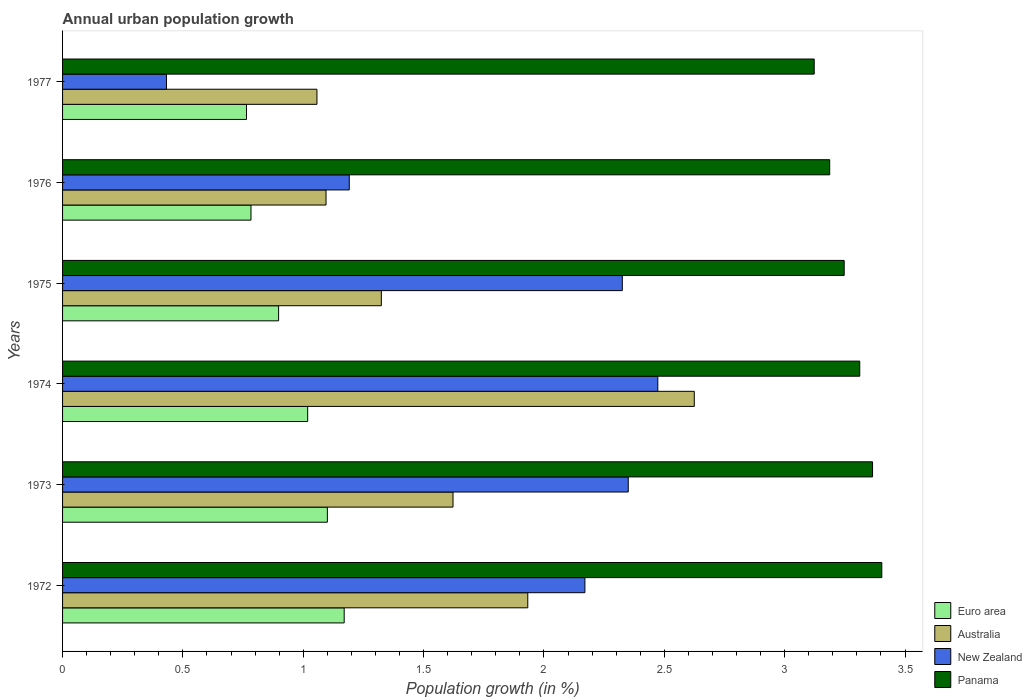How many groups of bars are there?
Offer a terse response. 6. Are the number of bars on each tick of the Y-axis equal?
Offer a terse response. Yes. How many bars are there on the 1st tick from the top?
Give a very brief answer. 4. How many bars are there on the 5th tick from the bottom?
Offer a very short reply. 4. What is the label of the 3rd group of bars from the top?
Keep it short and to the point. 1975. What is the percentage of urban population growth in Australia in 1975?
Make the answer very short. 1.32. Across all years, what is the maximum percentage of urban population growth in Australia?
Provide a succinct answer. 2.62. Across all years, what is the minimum percentage of urban population growth in Australia?
Keep it short and to the point. 1.06. In which year was the percentage of urban population growth in Euro area maximum?
Give a very brief answer. 1972. In which year was the percentage of urban population growth in Australia minimum?
Keep it short and to the point. 1977. What is the total percentage of urban population growth in New Zealand in the graph?
Offer a terse response. 10.94. What is the difference between the percentage of urban population growth in Panama in 1973 and that in 1974?
Your answer should be compact. 0.05. What is the difference between the percentage of urban population growth in Euro area in 1976 and the percentage of urban population growth in Australia in 1974?
Give a very brief answer. -1.84. What is the average percentage of urban population growth in Australia per year?
Your answer should be very brief. 1.61. In the year 1975, what is the difference between the percentage of urban population growth in Euro area and percentage of urban population growth in Australia?
Provide a succinct answer. -0.43. In how many years, is the percentage of urban population growth in New Zealand greater than 0.5 %?
Offer a terse response. 5. What is the ratio of the percentage of urban population growth in Australia in 1973 to that in 1976?
Provide a succinct answer. 1.48. What is the difference between the highest and the second highest percentage of urban population growth in Euro area?
Make the answer very short. 0.07. What is the difference between the highest and the lowest percentage of urban population growth in Panama?
Make the answer very short. 0.28. In how many years, is the percentage of urban population growth in Panama greater than the average percentage of urban population growth in Panama taken over all years?
Give a very brief answer. 3. Is it the case that in every year, the sum of the percentage of urban population growth in Panama and percentage of urban population growth in New Zealand is greater than the sum of percentage of urban population growth in Australia and percentage of urban population growth in Euro area?
Your answer should be compact. Yes. What does the 2nd bar from the top in 1976 represents?
Give a very brief answer. New Zealand. Is it the case that in every year, the sum of the percentage of urban population growth in Euro area and percentage of urban population growth in Panama is greater than the percentage of urban population growth in Australia?
Give a very brief answer. Yes. How many bars are there?
Your answer should be very brief. 24. Are all the bars in the graph horizontal?
Ensure brevity in your answer.  Yes. How many years are there in the graph?
Ensure brevity in your answer.  6. Are the values on the major ticks of X-axis written in scientific E-notation?
Your answer should be compact. No. Does the graph contain any zero values?
Your answer should be compact. No. Does the graph contain grids?
Give a very brief answer. No. How are the legend labels stacked?
Give a very brief answer. Vertical. What is the title of the graph?
Your answer should be compact. Annual urban population growth. Does "Cote d'Ivoire" appear as one of the legend labels in the graph?
Give a very brief answer. No. What is the label or title of the X-axis?
Keep it short and to the point. Population growth (in %). What is the label or title of the Y-axis?
Your response must be concise. Years. What is the Population growth (in %) in Euro area in 1972?
Provide a short and direct response. 1.17. What is the Population growth (in %) of Australia in 1972?
Offer a terse response. 1.93. What is the Population growth (in %) of New Zealand in 1972?
Provide a succinct answer. 2.17. What is the Population growth (in %) of Panama in 1972?
Offer a terse response. 3.4. What is the Population growth (in %) of Euro area in 1973?
Your response must be concise. 1.1. What is the Population growth (in %) of Australia in 1973?
Make the answer very short. 1.62. What is the Population growth (in %) of New Zealand in 1973?
Keep it short and to the point. 2.35. What is the Population growth (in %) in Panama in 1973?
Give a very brief answer. 3.37. What is the Population growth (in %) in Euro area in 1974?
Provide a short and direct response. 1.02. What is the Population growth (in %) of Australia in 1974?
Offer a very short reply. 2.62. What is the Population growth (in %) in New Zealand in 1974?
Keep it short and to the point. 2.47. What is the Population growth (in %) in Panama in 1974?
Provide a succinct answer. 3.31. What is the Population growth (in %) of Euro area in 1975?
Make the answer very short. 0.9. What is the Population growth (in %) in Australia in 1975?
Your answer should be very brief. 1.32. What is the Population growth (in %) of New Zealand in 1975?
Make the answer very short. 2.33. What is the Population growth (in %) in Panama in 1975?
Give a very brief answer. 3.25. What is the Population growth (in %) in Euro area in 1976?
Give a very brief answer. 0.78. What is the Population growth (in %) of Australia in 1976?
Give a very brief answer. 1.09. What is the Population growth (in %) of New Zealand in 1976?
Make the answer very short. 1.19. What is the Population growth (in %) in Panama in 1976?
Offer a terse response. 3.19. What is the Population growth (in %) of Euro area in 1977?
Your answer should be very brief. 0.76. What is the Population growth (in %) in Australia in 1977?
Your answer should be compact. 1.06. What is the Population growth (in %) in New Zealand in 1977?
Make the answer very short. 0.43. What is the Population growth (in %) of Panama in 1977?
Your answer should be very brief. 3.12. Across all years, what is the maximum Population growth (in %) of Euro area?
Your answer should be compact. 1.17. Across all years, what is the maximum Population growth (in %) of Australia?
Give a very brief answer. 2.62. Across all years, what is the maximum Population growth (in %) of New Zealand?
Keep it short and to the point. 2.47. Across all years, what is the maximum Population growth (in %) of Panama?
Ensure brevity in your answer.  3.4. Across all years, what is the minimum Population growth (in %) in Euro area?
Make the answer very short. 0.76. Across all years, what is the minimum Population growth (in %) of Australia?
Offer a terse response. 1.06. Across all years, what is the minimum Population growth (in %) in New Zealand?
Your answer should be compact. 0.43. Across all years, what is the minimum Population growth (in %) of Panama?
Your answer should be very brief. 3.12. What is the total Population growth (in %) in Euro area in the graph?
Your answer should be very brief. 5.73. What is the total Population growth (in %) of Australia in the graph?
Make the answer very short. 9.66. What is the total Population growth (in %) in New Zealand in the graph?
Ensure brevity in your answer.  10.94. What is the total Population growth (in %) in Panama in the graph?
Your answer should be compact. 19.64. What is the difference between the Population growth (in %) of Euro area in 1972 and that in 1973?
Give a very brief answer. 0.07. What is the difference between the Population growth (in %) in Australia in 1972 and that in 1973?
Your answer should be compact. 0.31. What is the difference between the Population growth (in %) in New Zealand in 1972 and that in 1973?
Your answer should be very brief. -0.18. What is the difference between the Population growth (in %) of Panama in 1972 and that in 1973?
Your response must be concise. 0.04. What is the difference between the Population growth (in %) of Euro area in 1972 and that in 1974?
Make the answer very short. 0.15. What is the difference between the Population growth (in %) of Australia in 1972 and that in 1974?
Your answer should be compact. -0.69. What is the difference between the Population growth (in %) in New Zealand in 1972 and that in 1974?
Offer a terse response. -0.3. What is the difference between the Population growth (in %) of Panama in 1972 and that in 1974?
Keep it short and to the point. 0.09. What is the difference between the Population growth (in %) of Euro area in 1972 and that in 1975?
Offer a terse response. 0.27. What is the difference between the Population growth (in %) in Australia in 1972 and that in 1975?
Offer a terse response. 0.61. What is the difference between the Population growth (in %) of New Zealand in 1972 and that in 1975?
Keep it short and to the point. -0.16. What is the difference between the Population growth (in %) of Panama in 1972 and that in 1975?
Give a very brief answer. 0.16. What is the difference between the Population growth (in %) of Euro area in 1972 and that in 1976?
Ensure brevity in your answer.  0.39. What is the difference between the Population growth (in %) of Australia in 1972 and that in 1976?
Provide a short and direct response. 0.84. What is the difference between the Population growth (in %) of New Zealand in 1972 and that in 1976?
Your answer should be compact. 0.98. What is the difference between the Population growth (in %) of Panama in 1972 and that in 1976?
Ensure brevity in your answer.  0.22. What is the difference between the Population growth (in %) in Euro area in 1972 and that in 1977?
Give a very brief answer. 0.41. What is the difference between the Population growth (in %) of Australia in 1972 and that in 1977?
Your response must be concise. 0.88. What is the difference between the Population growth (in %) of New Zealand in 1972 and that in 1977?
Your answer should be compact. 1.74. What is the difference between the Population growth (in %) in Panama in 1972 and that in 1977?
Offer a terse response. 0.28. What is the difference between the Population growth (in %) in Euro area in 1973 and that in 1974?
Offer a terse response. 0.08. What is the difference between the Population growth (in %) in Australia in 1973 and that in 1974?
Provide a succinct answer. -1. What is the difference between the Population growth (in %) of New Zealand in 1973 and that in 1974?
Your answer should be very brief. -0.12. What is the difference between the Population growth (in %) of Panama in 1973 and that in 1974?
Make the answer very short. 0.05. What is the difference between the Population growth (in %) in Euro area in 1973 and that in 1975?
Keep it short and to the point. 0.2. What is the difference between the Population growth (in %) in Australia in 1973 and that in 1975?
Provide a succinct answer. 0.3. What is the difference between the Population growth (in %) in New Zealand in 1973 and that in 1975?
Offer a very short reply. 0.02. What is the difference between the Population growth (in %) of Panama in 1973 and that in 1975?
Your response must be concise. 0.12. What is the difference between the Population growth (in %) of Euro area in 1973 and that in 1976?
Offer a terse response. 0.32. What is the difference between the Population growth (in %) of Australia in 1973 and that in 1976?
Provide a succinct answer. 0.53. What is the difference between the Population growth (in %) of New Zealand in 1973 and that in 1976?
Provide a short and direct response. 1.16. What is the difference between the Population growth (in %) of Panama in 1973 and that in 1976?
Offer a terse response. 0.18. What is the difference between the Population growth (in %) in Euro area in 1973 and that in 1977?
Ensure brevity in your answer.  0.34. What is the difference between the Population growth (in %) of Australia in 1973 and that in 1977?
Your response must be concise. 0.57. What is the difference between the Population growth (in %) in New Zealand in 1973 and that in 1977?
Your answer should be very brief. 1.92. What is the difference between the Population growth (in %) in Panama in 1973 and that in 1977?
Give a very brief answer. 0.24. What is the difference between the Population growth (in %) of Euro area in 1974 and that in 1975?
Provide a succinct answer. 0.12. What is the difference between the Population growth (in %) in Australia in 1974 and that in 1975?
Your answer should be very brief. 1.3. What is the difference between the Population growth (in %) of New Zealand in 1974 and that in 1975?
Make the answer very short. 0.15. What is the difference between the Population growth (in %) in Panama in 1974 and that in 1975?
Make the answer very short. 0.06. What is the difference between the Population growth (in %) of Euro area in 1974 and that in 1976?
Your answer should be very brief. 0.24. What is the difference between the Population growth (in %) of Australia in 1974 and that in 1976?
Your answer should be compact. 1.53. What is the difference between the Population growth (in %) of New Zealand in 1974 and that in 1976?
Give a very brief answer. 1.28. What is the difference between the Population growth (in %) in Panama in 1974 and that in 1976?
Provide a short and direct response. 0.12. What is the difference between the Population growth (in %) of Euro area in 1974 and that in 1977?
Give a very brief answer. 0.25. What is the difference between the Population growth (in %) of Australia in 1974 and that in 1977?
Your answer should be very brief. 1.57. What is the difference between the Population growth (in %) in New Zealand in 1974 and that in 1977?
Offer a very short reply. 2.04. What is the difference between the Population growth (in %) of Panama in 1974 and that in 1977?
Offer a very short reply. 0.19. What is the difference between the Population growth (in %) of Euro area in 1975 and that in 1976?
Make the answer very short. 0.11. What is the difference between the Population growth (in %) of Australia in 1975 and that in 1976?
Provide a short and direct response. 0.23. What is the difference between the Population growth (in %) of New Zealand in 1975 and that in 1976?
Provide a succinct answer. 1.13. What is the difference between the Population growth (in %) in Panama in 1975 and that in 1976?
Keep it short and to the point. 0.06. What is the difference between the Population growth (in %) in Euro area in 1975 and that in 1977?
Your response must be concise. 0.13. What is the difference between the Population growth (in %) in Australia in 1975 and that in 1977?
Provide a succinct answer. 0.27. What is the difference between the Population growth (in %) of New Zealand in 1975 and that in 1977?
Make the answer very short. 1.89. What is the difference between the Population growth (in %) of Panama in 1975 and that in 1977?
Offer a very short reply. 0.12. What is the difference between the Population growth (in %) in Euro area in 1976 and that in 1977?
Your answer should be very brief. 0.02. What is the difference between the Population growth (in %) of Australia in 1976 and that in 1977?
Your response must be concise. 0.04. What is the difference between the Population growth (in %) in New Zealand in 1976 and that in 1977?
Provide a succinct answer. 0.76. What is the difference between the Population growth (in %) of Panama in 1976 and that in 1977?
Give a very brief answer. 0.06. What is the difference between the Population growth (in %) of Euro area in 1972 and the Population growth (in %) of Australia in 1973?
Your answer should be compact. -0.45. What is the difference between the Population growth (in %) of Euro area in 1972 and the Population growth (in %) of New Zealand in 1973?
Give a very brief answer. -1.18. What is the difference between the Population growth (in %) in Euro area in 1972 and the Population growth (in %) in Panama in 1973?
Your answer should be compact. -2.2. What is the difference between the Population growth (in %) in Australia in 1972 and the Population growth (in %) in New Zealand in 1973?
Your response must be concise. -0.42. What is the difference between the Population growth (in %) in Australia in 1972 and the Population growth (in %) in Panama in 1973?
Your answer should be compact. -1.43. What is the difference between the Population growth (in %) of New Zealand in 1972 and the Population growth (in %) of Panama in 1973?
Make the answer very short. -1.2. What is the difference between the Population growth (in %) in Euro area in 1972 and the Population growth (in %) in Australia in 1974?
Provide a succinct answer. -1.45. What is the difference between the Population growth (in %) in Euro area in 1972 and the Population growth (in %) in New Zealand in 1974?
Keep it short and to the point. -1.3. What is the difference between the Population growth (in %) of Euro area in 1972 and the Population growth (in %) of Panama in 1974?
Offer a terse response. -2.14. What is the difference between the Population growth (in %) in Australia in 1972 and the Population growth (in %) in New Zealand in 1974?
Ensure brevity in your answer.  -0.54. What is the difference between the Population growth (in %) in Australia in 1972 and the Population growth (in %) in Panama in 1974?
Provide a succinct answer. -1.38. What is the difference between the Population growth (in %) of New Zealand in 1972 and the Population growth (in %) of Panama in 1974?
Your response must be concise. -1.14. What is the difference between the Population growth (in %) in Euro area in 1972 and the Population growth (in %) in Australia in 1975?
Provide a short and direct response. -0.15. What is the difference between the Population growth (in %) in Euro area in 1972 and the Population growth (in %) in New Zealand in 1975?
Provide a succinct answer. -1.16. What is the difference between the Population growth (in %) in Euro area in 1972 and the Population growth (in %) in Panama in 1975?
Provide a short and direct response. -2.08. What is the difference between the Population growth (in %) in Australia in 1972 and the Population growth (in %) in New Zealand in 1975?
Make the answer very short. -0.39. What is the difference between the Population growth (in %) of Australia in 1972 and the Population growth (in %) of Panama in 1975?
Your answer should be compact. -1.31. What is the difference between the Population growth (in %) in New Zealand in 1972 and the Population growth (in %) in Panama in 1975?
Provide a short and direct response. -1.08. What is the difference between the Population growth (in %) of Euro area in 1972 and the Population growth (in %) of Australia in 1976?
Ensure brevity in your answer.  0.08. What is the difference between the Population growth (in %) in Euro area in 1972 and the Population growth (in %) in New Zealand in 1976?
Offer a terse response. -0.02. What is the difference between the Population growth (in %) in Euro area in 1972 and the Population growth (in %) in Panama in 1976?
Ensure brevity in your answer.  -2.02. What is the difference between the Population growth (in %) in Australia in 1972 and the Population growth (in %) in New Zealand in 1976?
Make the answer very short. 0.74. What is the difference between the Population growth (in %) in Australia in 1972 and the Population growth (in %) in Panama in 1976?
Offer a very short reply. -1.25. What is the difference between the Population growth (in %) of New Zealand in 1972 and the Population growth (in %) of Panama in 1976?
Make the answer very short. -1.02. What is the difference between the Population growth (in %) in Euro area in 1972 and the Population growth (in %) in Australia in 1977?
Your answer should be very brief. 0.11. What is the difference between the Population growth (in %) in Euro area in 1972 and the Population growth (in %) in New Zealand in 1977?
Provide a short and direct response. 0.74. What is the difference between the Population growth (in %) of Euro area in 1972 and the Population growth (in %) of Panama in 1977?
Give a very brief answer. -1.95. What is the difference between the Population growth (in %) of Australia in 1972 and the Population growth (in %) of New Zealand in 1977?
Your answer should be very brief. 1.5. What is the difference between the Population growth (in %) of Australia in 1972 and the Population growth (in %) of Panama in 1977?
Provide a short and direct response. -1.19. What is the difference between the Population growth (in %) in New Zealand in 1972 and the Population growth (in %) in Panama in 1977?
Your response must be concise. -0.95. What is the difference between the Population growth (in %) in Euro area in 1973 and the Population growth (in %) in Australia in 1974?
Ensure brevity in your answer.  -1.52. What is the difference between the Population growth (in %) of Euro area in 1973 and the Population growth (in %) of New Zealand in 1974?
Give a very brief answer. -1.37. What is the difference between the Population growth (in %) of Euro area in 1973 and the Population growth (in %) of Panama in 1974?
Your answer should be compact. -2.21. What is the difference between the Population growth (in %) in Australia in 1973 and the Population growth (in %) in New Zealand in 1974?
Offer a terse response. -0.85. What is the difference between the Population growth (in %) in Australia in 1973 and the Population growth (in %) in Panama in 1974?
Your answer should be compact. -1.69. What is the difference between the Population growth (in %) of New Zealand in 1973 and the Population growth (in %) of Panama in 1974?
Offer a terse response. -0.96. What is the difference between the Population growth (in %) of Euro area in 1973 and the Population growth (in %) of Australia in 1975?
Your answer should be compact. -0.22. What is the difference between the Population growth (in %) of Euro area in 1973 and the Population growth (in %) of New Zealand in 1975?
Offer a very short reply. -1.23. What is the difference between the Population growth (in %) in Euro area in 1973 and the Population growth (in %) in Panama in 1975?
Provide a short and direct response. -2.15. What is the difference between the Population growth (in %) in Australia in 1973 and the Population growth (in %) in New Zealand in 1975?
Your answer should be compact. -0.7. What is the difference between the Population growth (in %) of Australia in 1973 and the Population growth (in %) of Panama in 1975?
Your answer should be compact. -1.63. What is the difference between the Population growth (in %) in New Zealand in 1973 and the Population growth (in %) in Panama in 1975?
Keep it short and to the point. -0.9. What is the difference between the Population growth (in %) in Euro area in 1973 and the Population growth (in %) in Australia in 1976?
Make the answer very short. 0.01. What is the difference between the Population growth (in %) in Euro area in 1973 and the Population growth (in %) in New Zealand in 1976?
Make the answer very short. -0.09. What is the difference between the Population growth (in %) in Euro area in 1973 and the Population growth (in %) in Panama in 1976?
Offer a very short reply. -2.09. What is the difference between the Population growth (in %) of Australia in 1973 and the Population growth (in %) of New Zealand in 1976?
Ensure brevity in your answer.  0.43. What is the difference between the Population growth (in %) in Australia in 1973 and the Population growth (in %) in Panama in 1976?
Your response must be concise. -1.56. What is the difference between the Population growth (in %) of New Zealand in 1973 and the Population growth (in %) of Panama in 1976?
Ensure brevity in your answer.  -0.84. What is the difference between the Population growth (in %) of Euro area in 1973 and the Population growth (in %) of Australia in 1977?
Ensure brevity in your answer.  0.04. What is the difference between the Population growth (in %) of Euro area in 1973 and the Population growth (in %) of New Zealand in 1977?
Offer a very short reply. 0.67. What is the difference between the Population growth (in %) in Euro area in 1973 and the Population growth (in %) in Panama in 1977?
Ensure brevity in your answer.  -2.02. What is the difference between the Population growth (in %) in Australia in 1973 and the Population growth (in %) in New Zealand in 1977?
Your answer should be compact. 1.19. What is the difference between the Population growth (in %) of Australia in 1973 and the Population growth (in %) of Panama in 1977?
Offer a terse response. -1.5. What is the difference between the Population growth (in %) in New Zealand in 1973 and the Population growth (in %) in Panama in 1977?
Give a very brief answer. -0.77. What is the difference between the Population growth (in %) of Euro area in 1974 and the Population growth (in %) of Australia in 1975?
Your answer should be compact. -0.31. What is the difference between the Population growth (in %) in Euro area in 1974 and the Population growth (in %) in New Zealand in 1975?
Keep it short and to the point. -1.31. What is the difference between the Population growth (in %) in Euro area in 1974 and the Population growth (in %) in Panama in 1975?
Provide a short and direct response. -2.23. What is the difference between the Population growth (in %) of Australia in 1974 and the Population growth (in %) of New Zealand in 1975?
Keep it short and to the point. 0.3. What is the difference between the Population growth (in %) in Australia in 1974 and the Population growth (in %) in Panama in 1975?
Offer a very short reply. -0.62. What is the difference between the Population growth (in %) of New Zealand in 1974 and the Population growth (in %) of Panama in 1975?
Your response must be concise. -0.77. What is the difference between the Population growth (in %) of Euro area in 1974 and the Population growth (in %) of Australia in 1976?
Ensure brevity in your answer.  -0.08. What is the difference between the Population growth (in %) of Euro area in 1974 and the Population growth (in %) of New Zealand in 1976?
Your response must be concise. -0.17. What is the difference between the Population growth (in %) in Euro area in 1974 and the Population growth (in %) in Panama in 1976?
Keep it short and to the point. -2.17. What is the difference between the Population growth (in %) in Australia in 1974 and the Population growth (in %) in New Zealand in 1976?
Your response must be concise. 1.43. What is the difference between the Population growth (in %) of Australia in 1974 and the Population growth (in %) of Panama in 1976?
Provide a short and direct response. -0.56. What is the difference between the Population growth (in %) of New Zealand in 1974 and the Population growth (in %) of Panama in 1976?
Give a very brief answer. -0.71. What is the difference between the Population growth (in %) of Euro area in 1974 and the Population growth (in %) of Australia in 1977?
Your answer should be compact. -0.04. What is the difference between the Population growth (in %) in Euro area in 1974 and the Population growth (in %) in New Zealand in 1977?
Provide a succinct answer. 0.59. What is the difference between the Population growth (in %) of Euro area in 1974 and the Population growth (in %) of Panama in 1977?
Provide a short and direct response. -2.1. What is the difference between the Population growth (in %) of Australia in 1974 and the Population growth (in %) of New Zealand in 1977?
Your response must be concise. 2.19. What is the difference between the Population growth (in %) in Australia in 1974 and the Population growth (in %) in Panama in 1977?
Your answer should be very brief. -0.5. What is the difference between the Population growth (in %) of New Zealand in 1974 and the Population growth (in %) of Panama in 1977?
Provide a short and direct response. -0.65. What is the difference between the Population growth (in %) in Euro area in 1975 and the Population growth (in %) in Australia in 1976?
Provide a short and direct response. -0.2. What is the difference between the Population growth (in %) in Euro area in 1975 and the Population growth (in %) in New Zealand in 1976?
Give a very brief answer. -0.29. What is the difference between the Population growth (in %) in Euro area in 1975 and the Population growth (in %) in Panama in 1976?
Give a very brief answer. -2.29. What is the difference between the Population growth (in %) in Australia in 1975 and the Population growth (in %) in New Zealand in 1976?
Provide a succinct answer. 0.13. What is the difference between the Population growth (in %) of Australia in 1975 and the Population growth (in %) of Panama in 1976?
Ensure brevity in your answer.  -1.86. What is the difference between the Population growth (in %) of New Zealand in 1975 and the Population growth (in %) of Panama in 1976?
Give a very brief answer. -0.86. What is the difference between the Population growth (in %) of Euro area in 1975 and the Population growth (in %) of Australia in 1977?
Keep it short and to the point. -0.16. What is the difference between the Population growth (in %) in Euro area in 1975 and the Population growth (in %) in New Zealand in 1977?
Offer a very short reply. 0.47. What is the difference between the Population growth (in %) of Euro area in 1975 and the Population growth (in %) of Panama in 1977?
Provide a succinct answer. -2.23. What is the difference between the Population growth (in %) of Australia in 1975 and the Population growth (in %) of New Zealand in 1977?
Ensure brevity in your answer.  0.89. What is the difference between the Population growth (in %) of Australia in 1975 and the Population growth (in %) of Panama in 1977?
Your response must be concise. -1.8. What is the difference between the Population growth (in %) in New Zealand in 1975 and the Population growth (in %) in Panama in 1977?
Offer a very short reply. -0.8. What is the difference between the Population growth (in %) in Euro area in 1976 and the Population growth (in %) in Australia in 1977?
Your answer should be very brief. -0.27. What is the difference between the Population growth (in %) in Euro area in 1976 and the Population growth (in %) in New Zealand in 1977?
Your response must be concise. 0.35. What is the difference between the Population growth (in %) in Euro area in 1976 and the Population growth (in %) in Panama in 1977?
Offer a very short reply. -2.34. What is the difference between the Population growth (in %) of Australia in 1976 and the Population growth (in %) of New Zealand in 1977?
Your answer should be very brief. 0.66. What is the difference between the Population growth (in %) in Australia in 1976 and the Population growth (in %) in Panama in 1977?
Your answer should be compact. -2.03. What is the difference between the Population growth (in %) of New Zealand in 1976 and the Population growth (in %) of Panama in 1977?
Your answer should be very brief. -1.93. What is the average Population growth (in %) in Euro area per year?
Make the answer very short. 0.96. What is the average Population growth (in %) in Australia per year?
Make the answer very short. 1.61. What is the average Population growth (in %) in New Zealand per year?
Offer a very short reply. 1.82. What is the average Population growth (in %) in Panama per year?
Provide a short and direct response. 3.27. In the year 1972, what is the difference between the Population growth (in %) in Euro area and Population growth (in %) in Australia?
Offer a very short reply. -0.76. In the year 1972, what is the difference between the Population growth (in %) of Euro area and Population growth (in %) of New Zealand?
Give a very brief answer. -1. In the year 1972, what is the difference between the Population growth (in %) of Euro area and Population growth (in %) of Panama?
Provide a short and direct response. -2.23. In the year 1972, what is the difference between the Population growth (in %) of Australia and Population growth (in %) of New Zealand?
Your answer should be compact. -0.24. In the year 1972, what is the difference between the Population growth (in %) in Australia and Population growth (in %) in Panama?
Your response must be concise. -1.47. In the year 1972, what is the difference between the Population growth (in %) of New Zealand and Population growth (in %) of Panama?
Your answer should be compact. -1.23. In the year 1973, what is the difference between the Population growth (in %) in Euro area and Population growth (in %) in Australia?
Give a very brief answer. -0.52. In the year 1973, what is the difference between the Population growth (in %) of Euro area and Population growth (in %) of New Zealand?
Your answer should be compact. -1.25. In the year 1973, what is the difference between the Population growth (in %) of Euro area and Population growth (in %) of Panama?
Ensure brevity in your answer.  -2.26. In the year 1973, what is the difference between the Population growth (in %) of Australia and Population growth (in %) of New Zealand?
Offer a terse response. -0.73. In the year 1973, what is the difference between the Population growth (in %) of Australia and Population growth (in %) of Panama?
Provide a succinct answer. -1.74. In the year 1973, what is the difference between the Population growth (in %) of New Zealand and Population growth (in %) of Panama?
Provide a succinct answer. -1.01. In the year 1974, what is the difference between the Population growth (in %) of Euro area and Population growth (in %) of Australia?
Your answer should be compact. -1.61. In the year 1974, what is the difference between the Population growth (in %) in Euro area and Population growth (in %) in New Zealand?
Offer a very short reply. -1.45. In the year 1974, what is the difference between the Population growth (in %) in Euro area and Population growth (in %) in Panama?
Give a very brief answer. -2.29. In the year 1974, what is the difference between the Population growth (in %) of Australia and Population growth (in %) of New Zealand?
Keep it short and to the point. 0.15. In the year 1974, what is the difference between the Population growth (in %) of Australia and Population growth (in %) of Panama?
Your response must be concise. -0.69. In the year 1974, what is the difference between the Population growth (in %) of New Zealand and Population growth (in %) of Panama?
Provide a succinct answer. -0.84. In the year 1975, what is the difference between the Population growth (in %) of Euro area and Population growth (in %) of Australia?
Offer a terse response. -0.43. In the year 1975, what is the difference between the Population growth (in %) in Euro area and Population growth (in %) in New Zealand?
Offer a terse response. -1.43. In the year 1975, what is the difference between the Population growth (in %) of Euro area and Population growth (in %) of Panama?
Offer a very short reply. -2.35. In the year 1975, what is the difference between the Population growth (in %) of Australia and Population growth (in %) of New Zealand?
Your response must be concise. -1. In the year 1975, what is the difference between the Population growth (in %) in Australia and Population growth (in %) in Panama?
Give a very brief answer. -1.92. In the year 1975, what is the difference between the Population growth (in %) in New Zealand and Population growth (in %) in Panama?
Provide a succinct answer. -0.92. In the year 1976, what is the difference between the Population growth (in %) of Euro area and Population growth (in %) of Australia?
Ensure brevity in your answer.  -0.31. In the year 1976, what is the difference between the Population growth (in %) of Euro area and Population growth (in %) of New Zealand?
Provide a succinct answer. -0.41. In the year 1976, what is the difference between the Population growth (in %) in Euro area and Population growth (in %) in Panama?
Give a very brief answer. -2.4. In the year 1976, what is the difference between the Population growth (in %) in Australia and Population growth (in %) in New Zealand?
Make the answer very short. -0.1. In the year 1976, what is the difference between the Population growth (in %) in Australia and Population growth (in %) in Panama?
Make the answer very short. -2.09. In the year 1976, what is the difference between the Population growth (in %) of New Zealand and Population growth (in %) of Panama?
Ensure brevity in your answer.  -2. In the year 1977, what is the difference between the Population growth (in %) of Euro area and Population growth (in %) of Australia?
Your answer should be very brief. -0.29. In the year 1977, what is the difference between the Population growth (in %) in Euro area and Population growth (in %) in New Zealand?
Provide a succinct answer. 0.33. In the year 1977, what is the difference between the Population growth (in %) of Euro area and Population growth (in %) of Panama?
Your answer should be very brief. -2.36. In the year 1977, what is the difference between the Population growth (in %) in Australia and Population growth (in %) in New Zealand?
Give a very brief answer. 0.63. In the year 1977, what is the difference between the Population growth (in %) of Australia and Population growth (in %) of Panama?
Your response must be concise. -2.07. In the year 1977, what is the difference between the Population growth (in %) in New Zealand and Population growth (in %) in Panama?
Give a very brief answer. -2.69. What is the ratio of the Population growth (in %) in Euro area in 1972 to that in 1973?
Provide a short and direct response. 1.06. What is the ratio of the Population growth (in %) in Australia in 1972 to that in 1973?
Ensure brevity in your answer.  1.19. What is the ratio of the Population growth (in %) in New Zealand in 1972 to that in 1973?
Offer a terse response. 0.92. What is the ratio of the Population growth (in %) of Panama in 1972 to that in 1973?
Your answer should be compact. 1.01. What is the ratio of the Population growth (in %) in Euro area in 1972 to that in 1974?
Your answer should be very brief. 1.15. What is the ratio of the Population growth (in %) of Australia in 1972 to that in 1974?
Give a very brief answer. 0.74. What is the ratio of the Population growth (in %) of New Zealand in 1972 to that in 1974?
Give a very brief answer. 0.88. What is the ratio of the Population growth (in %) in Panama in 1972 to that in 1974?
Provide a succinct answer. 1.03. What is the ratio of the Population growth (in %) in Euro area in 1972 to that in 1975?
Provide a short and direct response. 1.3. What is the ratio of the Population growth (in %) of Australia in 1972 to that in 1975?
Keep it short and to the point. 1.46. What is the ratio of the Population growth (in %) of New Zealand in 1972 to that in 1975?
Your answer should be compact. 0.93. What is the ratio of the Population growth (in %) in Panama in 1972 to that in 1975?
Offer a very short reply. 1.05. What is the ratio of the Population growth (in %) of Euro area in 1972 to that in 1976?
Give a very brief answer. 1.49. What is the ratio of the Population growth (in %) of Australia in 1972 to that in 1976?
Provide a succinct answer. 1.77. What is the ratio of the Population growth (in %) of New Zealand in 1972 to that in 1976?
Ensure brevity in your answer.  1.82. What is the ratio of the Population growth (in %) of Panama in 1972 to that in 1976?
Your response must be concise. 1.07. What is the ratio of the Population growth (in %) in Euro area in 1972 to that in 1977?
Your response must be concise. 1.53. What is the ratio of the Population growth (in %) in Australia in 1972 to that in 1977?
Ensure brevity in your answer.  1.83. What is the ratio of the Population growth (in %) of New Zealand in 1972 to that in 1977?
Provide a succinct answer. 5.03. What is the ratio of the Population growth (in %) in Panama in 1972 to that in 1977?
Your answer should be compact. 1.09. What is the ratio of the Population growth (in %) in Euro area in 1973 to that in 1974?
Keep it short and to the point. 1.08. What is the ratio of the Population growth (in %) of Australia in 1973 to that in 1974?
Provide a succinct answer. 0.62. What is the ratio of the Population growth (in %) in New Zealand in 1973 to that in 1974?
Your answer should be compact. 0.95. What is the ratio of the Population growth (in %) in Panama in 1973 to that in 1974?
Offer a terse response. 1.02. What is the ratio of the Population growth (in %) of Euro area in 1973 to that in 1975?
Your response must be concise. 1.23. What is the ratio of the Population growth (in %) in Australia in 1973 to that in 1975?
Keep it short and to the point. 1.22. What is the ratio of the Population growth (in %) in New Zealand in 1973 to that in 1975?
Give a very brief answer. 1.01. What is the ratio of the Population growth (in %) of Panama in 1973 to that in 1975?
Offer a very short reply. 1.04. What is the ratio of the Population growth (in %) of Euro area in 1973 to that in 1976?
Provide a succinct answer. 1.41. What is the ratio of the Population growth (in %) of Australia in 1973 to that in 1976?
Ensure brevity in your answer.  1.48. What is the ratio of the Population growth (in %) in New Zealand in 1973 to that in 1976?
Your answer should be very brief. 1.97. What is the ratio of the Population growth (in %) of Panama in 1973 to that in 1976?
Provide a succinct answer. 1.06. What is the ratio of the Population growth (in %) in Euro area in 1973 to that in 1977?
Your answer should be very brief. 1.44. What is the ratio of the Population growth (in %) of Australia in 1973 to that in 1977?
Give a very brief answer. 1.53. What is the ratio of the Population growth (in %) of New Zealand in 1973 to that in 1977?
Give a very brief answer. 5.44. What is the ratio of the Population growth (in %) in Panama in 1973 to that in 1977?
Make the answer very short. 1.08. What is the ratio of the Population growth (in %) of Euro area in 1974 to that in 1975?
Your answer should be very brief. 1.13. What is the ratio of the Population growth (in %) of Australia in 1974 to that in 1975?
Your response must be concise. 1.98. What is the ratio of the Population growth (in %) in New Zealand in 1974 to that in 1975?
Provide a succinct answer. 1.06. What is the ratio of the Population growth (in %) of Panama in 1974 to that in 1975?
Give a very brief answer. 1.02. What is the ratio of the Population growth (in %) in Euro area in 1974 to that in 1976?
Ensure brevity in your answer.  1.3. What is the ratio of the Population growth (in %) of Australia in 1974 to that in 1976?
Provide a succinct answer. 2.4. What is the ratio of the Population growth (in %) in New Zealand in 1974 to that in 1976?
Your response must be concise. 2.08. What is the ratio of the Population growth (in %) of Panama in 1974 to that in 1976?
Provide a short and direct response. 1.04. What is the ratio of the Population growth (in %) of Euro area in 1974 to that in 1977?
Your answer should be very brief. 1.33. What is the ratio of the Population growth (in %) of Australia in 1974 to that in 1977?
Offer a terse response. 2.48. What is the ratio of the Population growth (in %) of New Zealand in 1974 to that in 1977?
Your answer should be compact. 5.73. What is the ratio of the Population growth (in %) in Panama in 1974 to that in 1977?
Your response must be concise. 1.06. What is the ratio of the Population growth (in %) of Euro area in 1975 to that in 1976?
Offer a terse response. 1.15. What is the ratio of the Population growth (in %) in Australia in 1975 to that in 1976?
Ensure brevity in your answer.  1.21. What is the ratio of the Population growth (in %) of New Zealand in 1975 to that in 1976?
Provide a succinct answer. 1.95. What is the ratio of the Population growth (in %) in Panama in 1975 to that in 1976?
Your response must be concise. 1.02. What is the ratio of the Population growth (in %) in Euro area in 1975 to that in 1977?
Provide a short and direct response. 1.17. What is the ratio of the Population growth (in %) of Australia in 1975 to that in 1977?
Offer a very short reply. 1.25. What is the ratio of the Population growth (in %) of New Zealand in 1975 to that in 1977?
Provide a succinct answer. 5.39. What is the ratio of the Population growth (in %) of Panama in 1975 to that in 1977?
Your answer should be compact. 1.04. What is the ratio of the Population growth (in %) in Euro area in 1976 to that in 1977?
Your response must be concise. 1.02. What is the ratio of the Population growth (in %) in Australia in 1976 to that in 1977?
Provide a succinct answer. 1.04. What is the ratio of the Population growth (in %) in New Zealand in 1976 to that in 1977?
Ensure brevity in your answer.  2.76. What is the ratio of the Population growth (in %) of Panama in 1976 to that in 1977?
Make the answer very short. 1.02. What is the difference between the highest and the second highest Population growth (in %) in Euro area?
Provide a short and direct response. 0.07. What is the difference between the highest and the second highest Population growth (in %) of Australia?
Give a very brief answer. 0.69. What is the difference between the highest and the second highest Population growth (in %) in New Zealand?
Ensure brevity in your answer.  0.12. What is the difference between the highest and the second highest Population growth (in %) of Panama?
Offer a very short reply. 0.04. What is the difference between the highest and the lowest Population growth (in %) in Euro area?
Give a very brief answer. 0.41. What is the difference between the highest and the lowest Population growth (in %) of Australia?
Offer a very short reply. 1.57. What is the difference between the highest and the lowest Population growth (in %) of New Zealand?
Give a very brief answer. 2.04. What is the difference between the highest and the lowest Population growth (in %) of Panama?
Make the answer very short. 0.28. 